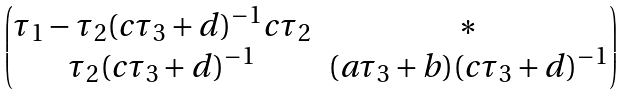<formula> <loc_0><loc_0><loc_500><loc_500>\begin{pmatrix} \tau _ { 1 } - \tau _ { 2 } ( c \tau _ { 3 } + d ) ^ { - 1 } c \tau _ { 2 } & \ast \\ \tau _ { 2 } ( c \tau _ { 3 } + d ) ^ { - 1 } & ( a \tau _ { 3 } + b ) ( c \tau _ { 3 } + d ) ^ { - 1 } \end{pmatrix}</formula> 